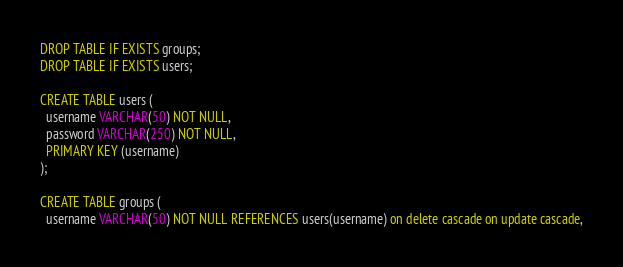Convert code to text. <code><loc_0><loc_0><loc_500><loc_500><_SQL_>DROP TABLE IF EXISTS groups;
DROP TABLE IF EXISTS users;

CREATE TABLE users (
  username VARCHAR(50) NOT NULL,
  password VARCHAR(250) NOT NULL,
  PRIMARY KEY (username)
);
  
CREATE TABLE groups (
  username VARCHAR(50) NOT NULL REFERENCES users(username) on delete cascade on update cascade,</code> 